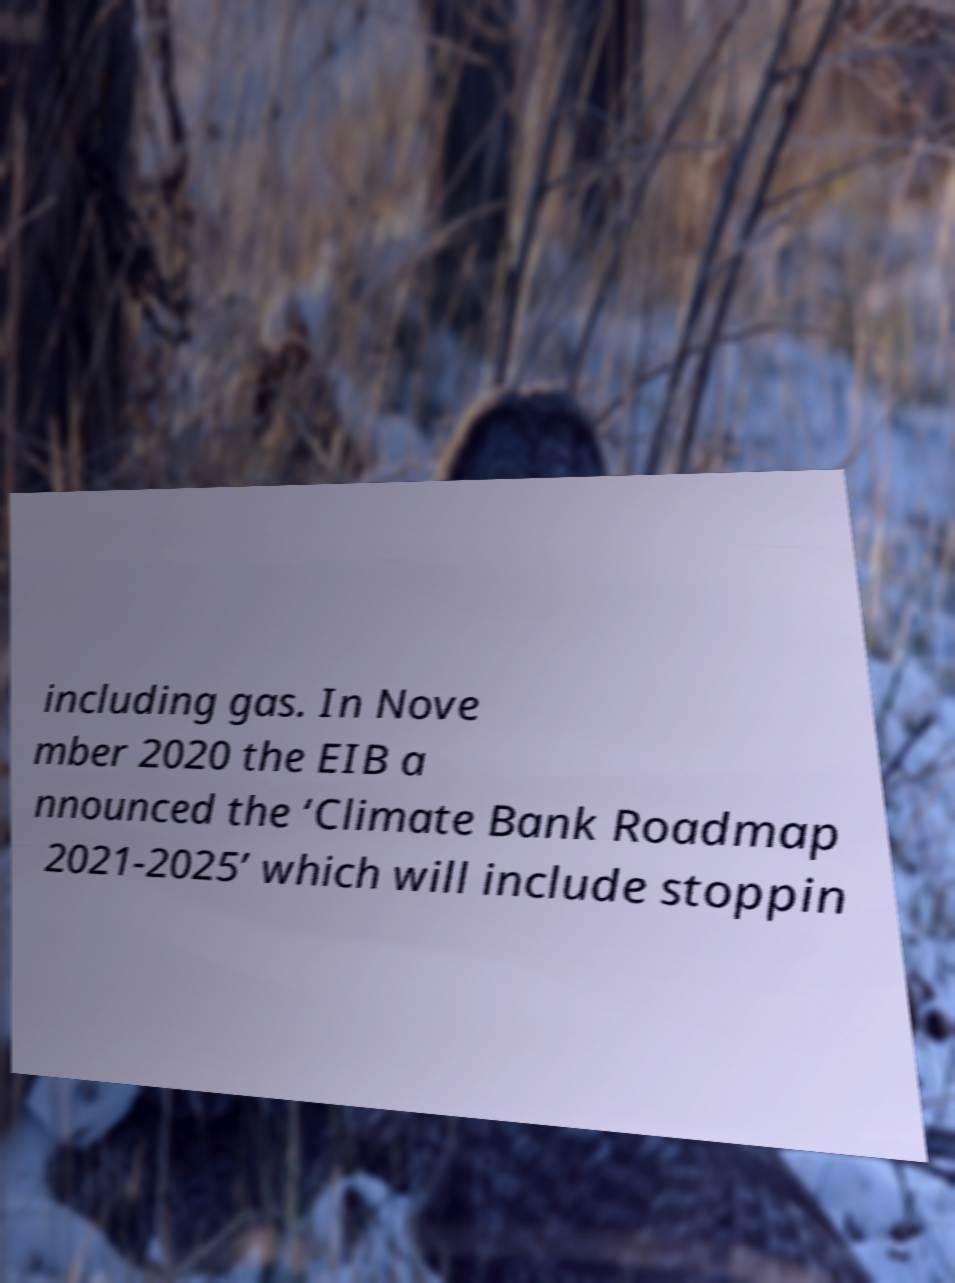There's text embedded in this image that I need extracted. Can you transcribe it verbatim? including gas. In Nove mber 2020 the EIB a nnounced the ‘Climate Bank Roadmap 2021-2025’ which will include stoppin 